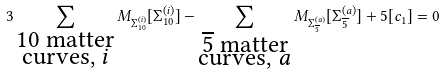<formula> <loc_0><loc_0><loc_500><loc_500>3 \sum _ { \substack { 1 0 \text { matter} \\ \text {curves, } i } } M _ { \Sigma _ { 1 0 } ^ { ( i ) } } [ \Sigma _ { 1 0 } ^ { ( i ) } ] - \sum _ { \substack { \overline { 5 } \text { matter} \\ \text {curves, } a } } M _ { \Sigma _ { \overline { 5 } } ^ { ( a ) } } [ \Sigma _ { \overline { 5 } } ^ { ( a ) } ] + 5 [ c _ { 1 } ] = 0</formula> 